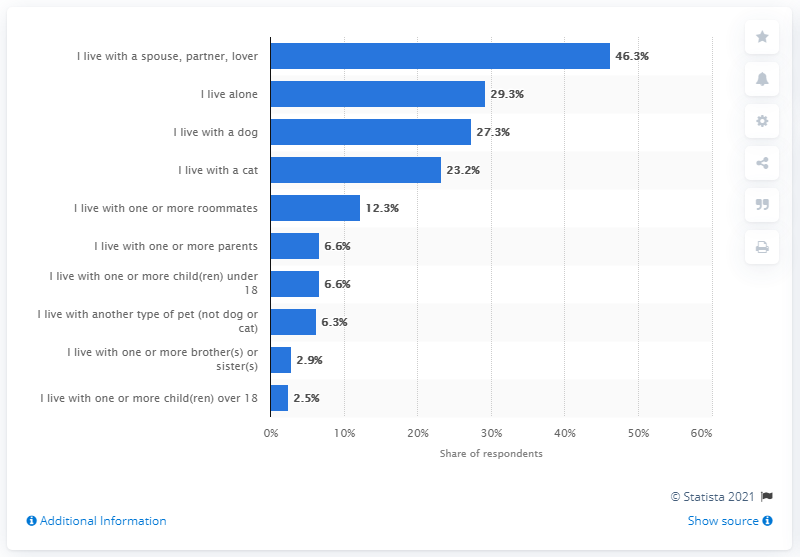Outline some significant characteristics in this image. According to a survey of gay and lesbian Americans, 29.3% reported living alone. 